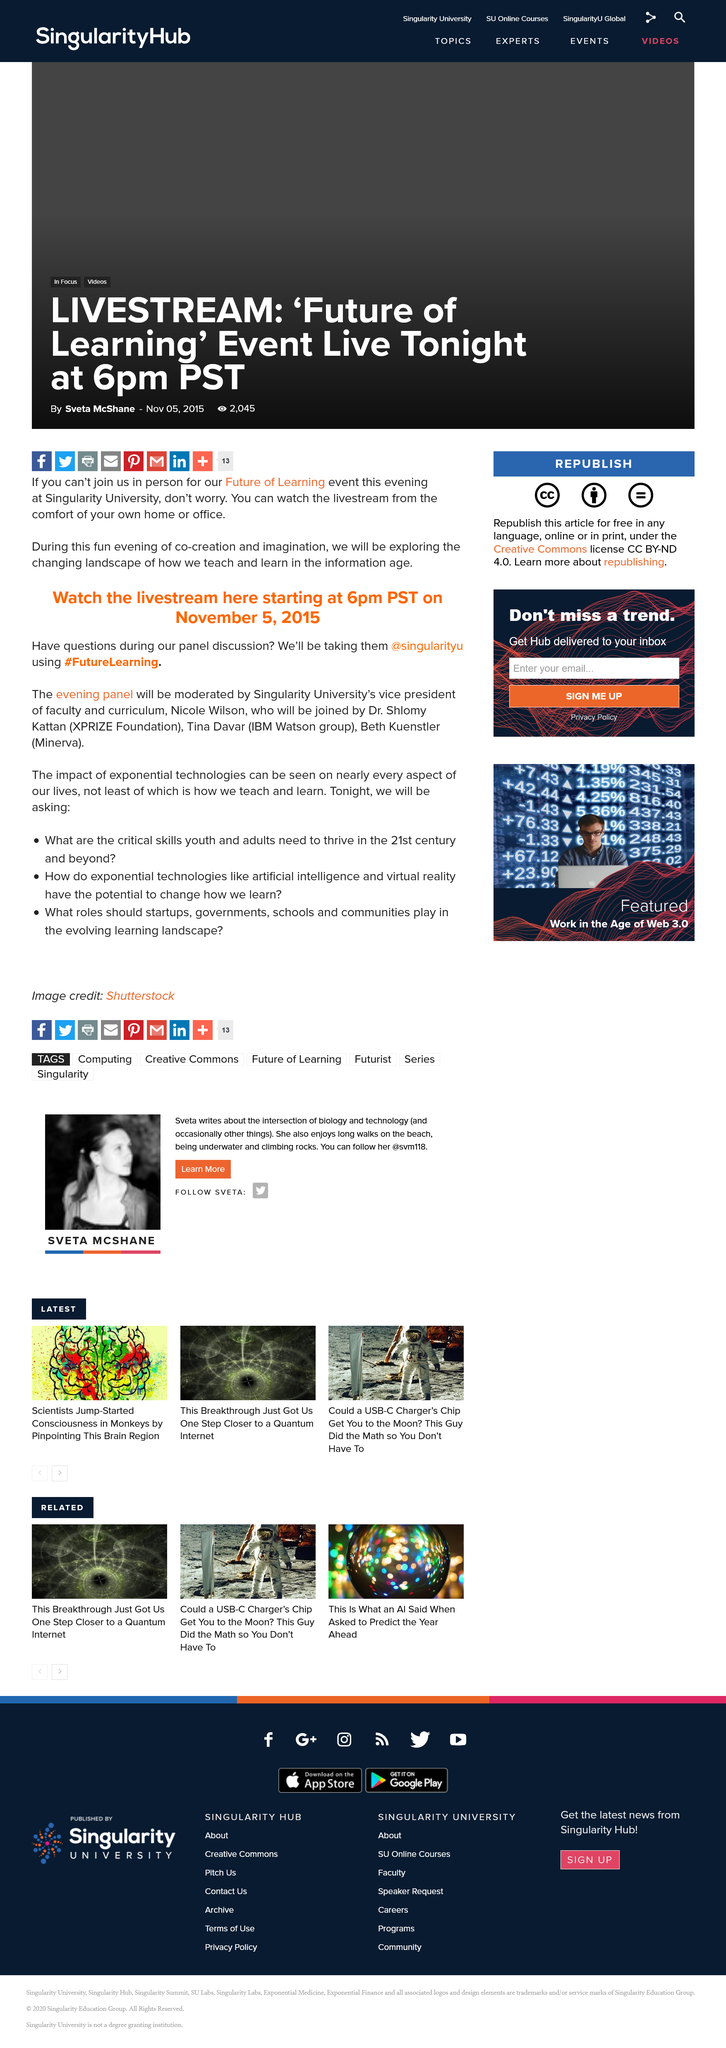Give some essential details in this illustration. The hashtag "#FutureLearning" is used for a panel discussion. The article contains three questions. The title of the livestream is "Watch the livestream here starting at 6pm PST on November 5 2015. 